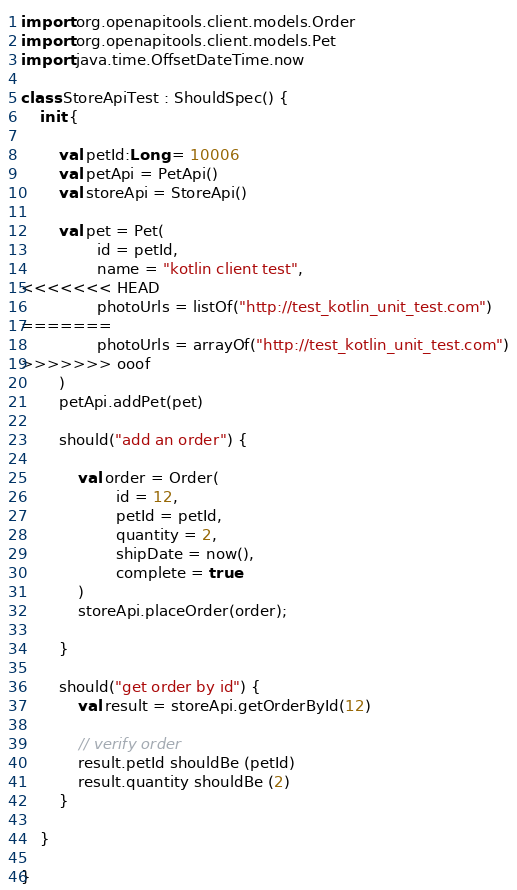<code> <loc_0><loc_0><loc_500><loc_500><_Kotlin_>import org.openapitools.client.models.Order
import org.openapitools.client.models.Pet
import java.time.OffsetDateTime.now

class StoreApiTest : ShouldSpec() {
    init {

        val petId:Long = 10006
        val petApi = PetApi()
        val storeApi = StoreApi()

        val pet = Pet(
                id = petId,
                name = "kotlin client test",
<<<<<<< HEAD
                photoUrls = listOf("http://test_kotlin_unit_test.com")
=======
                photoUrls = arrayOf("http://test_kotlin_unit_test.com")
>>>>>>> ooof
        )
        petApi.addPet(pet)

        should("add an order") {

            val order = Order(
                    id = 12,
                    petId = petId,
                    quantity = 2,
                    shipDate = now(),
                    complete = true
            )
            storeApi.placeOrder(order);

        }

        should("get order by id") {
            val result = storeApi.getOrderById(12)

            // verify order
            result.petId shouldBe (petId)
            result.quantity shouldBe (2)
        }

    }

}
</code> 